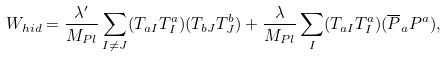<formula> <loc_0><loc_0><loc_500><loc_500>W _ { h i d } = \frac { \lambda ^ { \prime } } { M _ { P l } } \sum _ { I \neq J } ( T _ { a I } T ^ { a } _ { I } ) ( T _ { b J } T ^ { b } _ { J } ) + \frac { \lambda } { M _ { P l } } \sum _ { I } ( T _ { a I } T ^ { a } _ { I } ) ( \overline { P } _ { a } P ^ { a } ) ,</formula> 